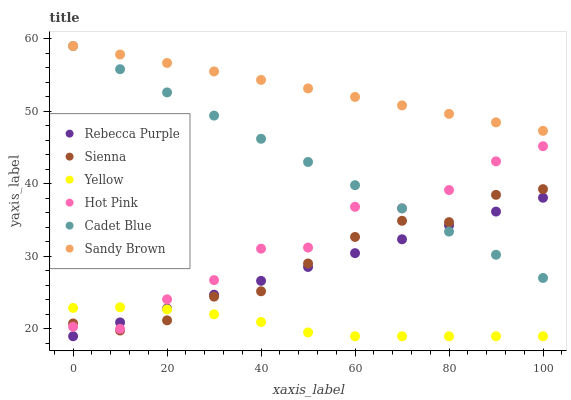Does Yellow have the minimum area under the curve?
Answer yes or no. Yes. Does Sandy Brown have the maximum area under the curve?
Answer yes or no. Yes. Does Hot Pink have the minimum area under the curve?
Answer yes or no. No. Does Hot Pink have the maximum area under the curve?
Answer yes or no. No. Is Rebecca Purple the smoothest?
Answer yes or no. Yes. Is Hot Pink the roughest?
Answer yes or no. Yes. Is Yellow the smoothest?
Answer yes or no. No. Is Yellow the roughest?
Answer yes or no. No. Does Yellow have the lowest value?
Answer yes or no. Yes. Does Hot Pink have the lowest value?
Answer yes or no. No. Does Sandy Brown have the highest value?
Answer yes or no. Yes. Does Hot Pink have the highest value?
Answer yes or no. No. Is Yellow less than Cadet Blue?
Answer yes or no. Yes. Is Sandy Brown greater than Sienna?
Answer yes or no. Yes. Does Cadet Blue intersect Hot Pink?
Answer yes or no. Yes. Is Cadet Blue less than Hot Pink?
Answer yes or no. No. Is Cadet Blue greater than Hot Pink?
Answer yes or no. No. Does Yellow intersect Cadet Blue?
Answer yes or no. No. 